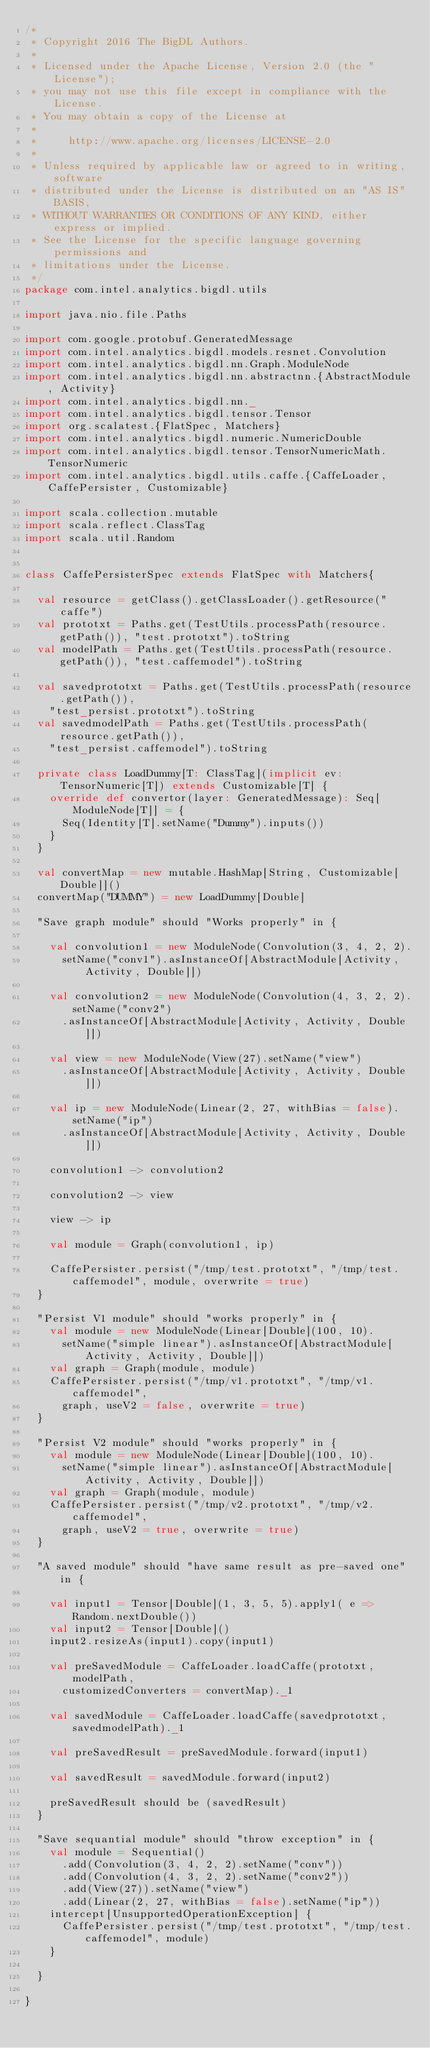<code> <loc_0><loc_0><loc_500><loc_500><_Scala_>/*
 * Copyright 2016 The BigDL Authors.
 *
 * Licensed under the Apache License, Version 2.0 (the "License");
 * you may not use this file except in compliance with the License.
 * You may obtain a copy of the License at
 *
 *     http://www.apache.org/licenses/LICENSE-2.0
 *
 * Unless required by applicable law or agreed to in writing, software
 * distributed under the License is distributed on an "AS IS" BASIS,
 * WITHOUT WARRANTIES OR CONDITIONS OF ANY KIND, either express or implied.
 * See the License for the specific language governing permissions and
 * limitations under the License.
 */
package com.intel.analytics.bigdl.utils

import java.nio.file.Paths

import com.google.protobuf.GeneratedMessage
import com.intel.analytics.bigdl.models.resnet.Convolution
import com.intel.analytics.bigdl.nn.Graph.ModuleNode
import com.intel.analytics.bigdl.nn.abstractnn.{AbstractModule, Activity}
import com.intel.analytics.bigdl.nn._
import com.intel.analytics.bigdl.tensor.Tensor
import org.scalatest.{FlatSpec, Matchers}
import com.intel.analytics.bigdl.numeric.NumericDouble
import com.intel.analytics.bigdl.tensor.TensorNumericMath.TensorNumeric
import com.intel.analytics.bigdl.utils.caffe.{CaffeLoader, CaffePersister, Customizable}

import scala.collection.mutable
import scala.reflect.ClassTag
import scala.util.Random


class CaffePersisterSpec extends FlatSpec with Matchers{

  val resource = getClass().getClassLoader().getResource("caffe")
  val prototxt = Paths.get(TestUtils.processPath(resource.getPath()), "test.prototxt").toString
  val modelPath = Paths.get(TestUtils.processPath(resource.getPath()), "test.caffemodel").toString

  val savedprototxt = Paths.get(TestUtils.processPath(resource.getPath()),
    "test_persist.prototxt").toString
  val savedmodelPath = Paths.get(TestUtils.processPath(resource.getPath()),
    "test_persist.caffemodel").toString

  private class LoadDummy[T: ClassTag](implicit ev: TensorNumeric[T]) extends Customizable[T] {
    override def convertor(layer: GeneratedMessage): Seq[ModuleNode[T]] = {
      Seq(Identity[T].setName("Dummy").inputs())
    }
  }

  val convertMap = new mutable.HashMap[String, Customizable[Double]]()
  convertMap("DUMMY") = new LoadDummy[Double]

  "Save graph module" should "Works properly" in {

    val convolution1 = new ModuleNode(Convolution(3, 4, 2, 2).
      setName("conv1").asInstanceOf[AbstractModule[Activity, Activity, Double]])

    val convolution2 = new ModuleNode(Convolution(4, 3, 2, 2).setName("conv2")
      .asInstanceOf[AbstractModule[Activity, Activity, Double]])

    val view = new ModuleNode(View(27).setName("view")
      .asInstanceOf[AbstractModule[Activity, Activity, Double]])

    val ip = new ModuleNode(Linear(2, 27, withBias = false).setName("ip")
      .asInstanceOf[AbstractModule[Activity, Activity, Double]])

    convolution1 -> convolution2

    convolution2 -> view

    view -> ip

    val module = Graph(convolution1, ip)

    CaffePersister.persist("/tmp/test.prototxt", "/tmp/test.caffemodel", module, overwrite = true)
  }

  "Persist V1 module" should "works properly" in {
    val module = new ModuleNode(Linear[Double](100, 10).
      setName("simple linear").asInstanceOf[AbstractModule[Activity, Activity, Double]])
    val graph = Graph(module, module)
    CaffePersister.persist("/tmp/v1.prototxt", "/tmp/v1.caffemodel",
      graph, useV2 = false, overwrite = true)
  }

  "Persist V2 module" should "works properly" in {
    val module = new ModuleNode(Linear[Double](100, 10).
      setName("simple linear").asInstanceOf[AbstractModule[Activity, Activity, Double]])
    val graph = Graph(module, module)
    CaffePersister.persist("/tmp/v2.prototxt", "/tmp/v2.caffemodel",
      graph, useV2 = true, overwrite = true)
  }

  "A saved module" should "have same result as pre-saved one" in {

    val input1 = Tensor[Double](1, 3, 5, 5).apply1( e => Random.nextDouble())
    val input2 = Tensor[Double]()
    input2.resizeAs(input1).copy(input1)

    val preSavedModule = CaffeLoader.loadCaffe(prototxt, modelPath,
      customizedConverters = convertMap)._1

    val savedModule = CaffeLoader.loadCaffe(savedprototxt, savedmodelPath)._1

    val preSavedResult = preSavedModule.forward(input1)

    val savedResult = savedModule.forward(input2)

    preSavedResult should be (savedResult)
  }

  "Save sequantial module" should "throw exception" in {
    val module = Sequential()
      .add(Convolution(3, 4, 2, 2).setName("conv"))
      .add(Convolution(4, 3, 2, 2).setName("conv2"))
      .add(View(27)).setName("view")
      .add(Linear(2, 27, withBias = false).setName("ip"))
    intercept[UnsupportedOperationException] {
      CaffePersister.persist("/tmp/test.prototxt", "/tmp/test.caffemodel", module)
    }

  }

}
</code> 